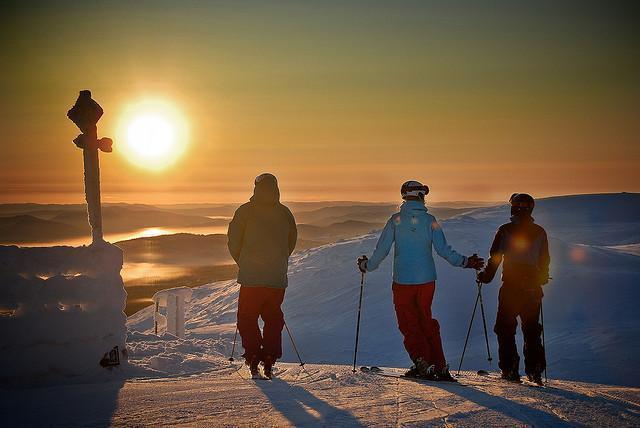What are the skiers watching?
Select the accurate answer and provide explanation: 'Answer: answer
Rationale: rationale.'
Options: Moon, sun, stars, clouds. Answer: sun.
Rationale: He's watching the sun. 